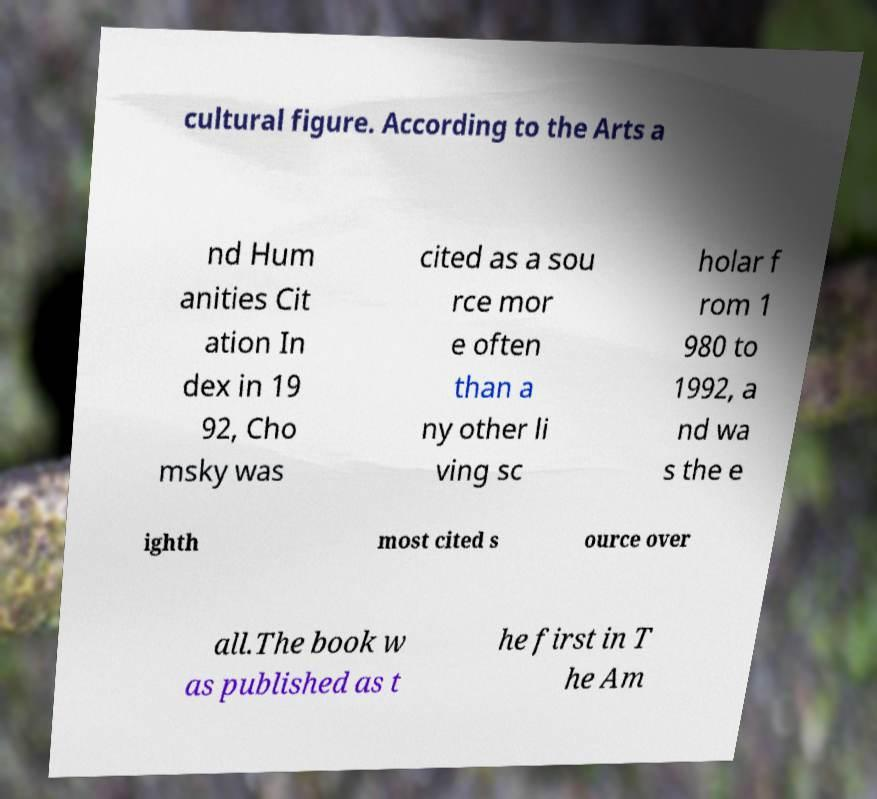What messages or text are displayed in this image? I need them in a readable, typed format. cultural figure. According to the Arts a nd Hum anities Cit ation In dex in 19 92, Cho msky was cited as a sou rce mor e often than a ny other li ving sc holar f rom 1 980 to 1992, a nd wa s the e ighth most cited s ource over all.The book w as published as t he first in T he Am 